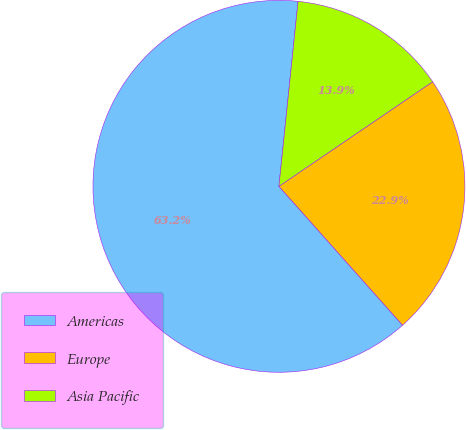Convert chart. <chart><loc_0><loc_0><loc_500><loc_500><pie_chart><fcel>Americas<fcel>Europe<fcel>Asia Pacific<nl><fcel>63.21%<fcel>22.93%<fcel>13.85%<nl></chart> 